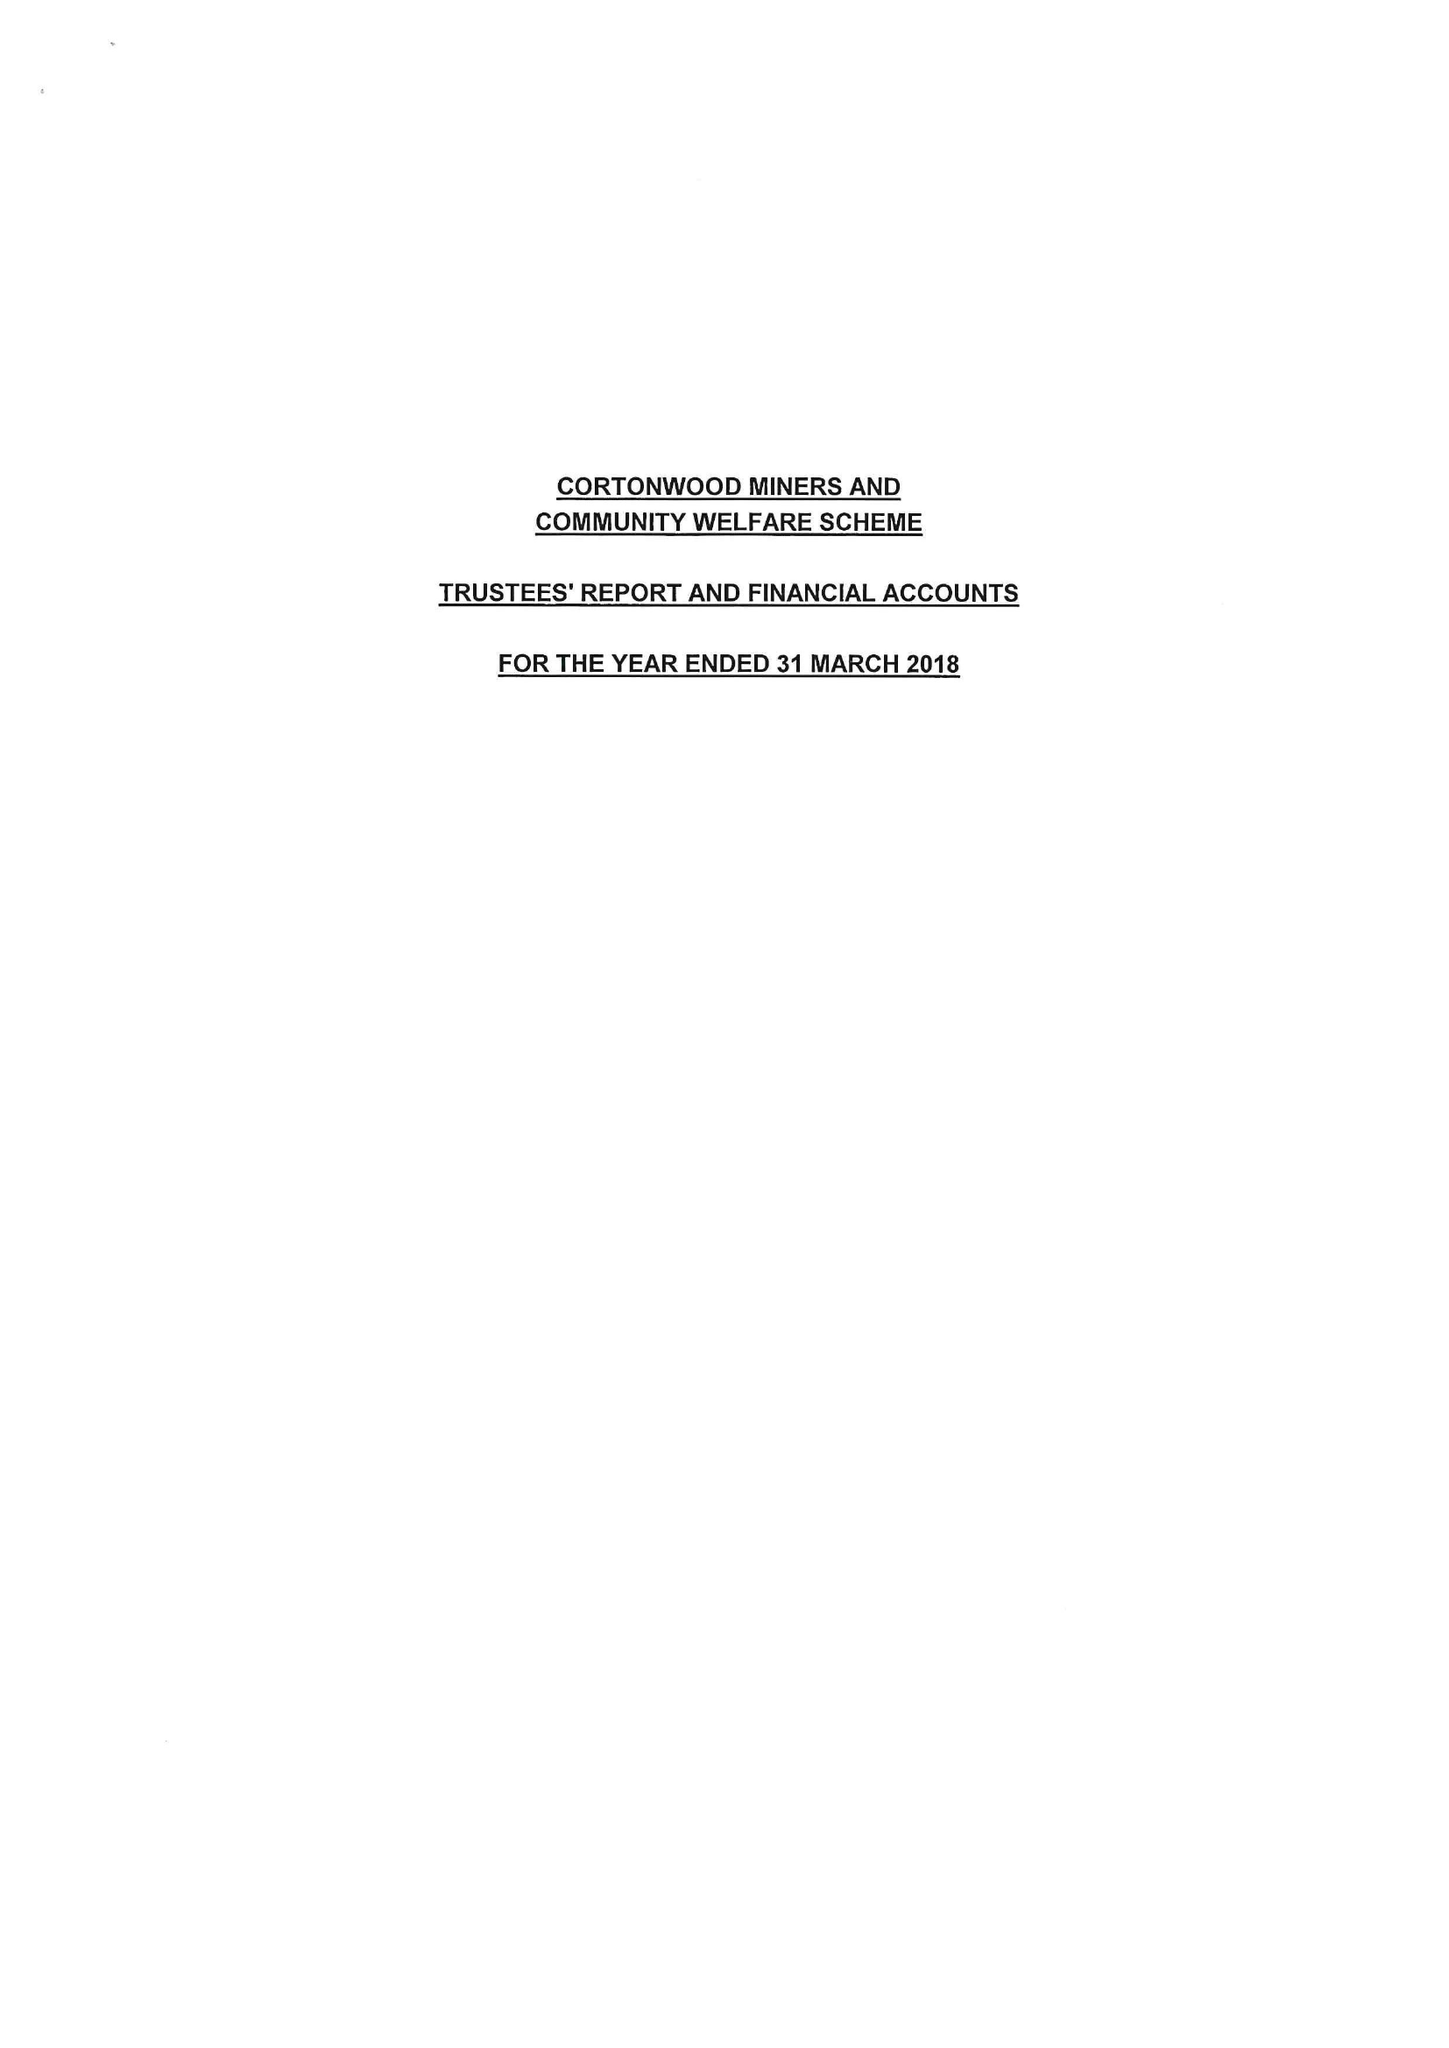What is the value for the address__postcode?
Answer the question using a single word or phrase. S73 0TU 